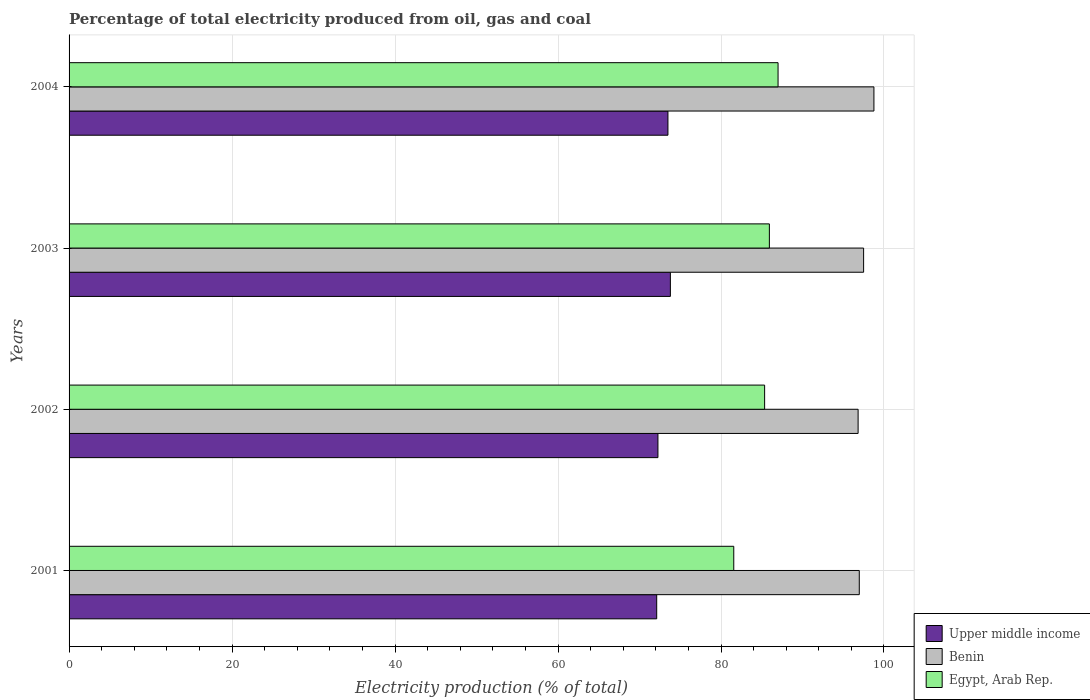Are the number of bars per tick equal to the number of legend labels?
Offer a terse response. Yes. What is the label of the 2nd group of bars from the top?
Ensure brevity in your answer.  2003. What is the electricity production in in Benin in 2001?
Provide a short and direct response. 96.97. Across all years, what is the maximum electricity production in in Egypt, Arab Rep.?
Provide a short and direct response. 87. Across all years, what is the minimum electricity production in in Upper middle income?
Your answer should be very brief. 72.11. In which year was the electricity production in in Egypt, Arab Rep. minimum?
Your answer should be compact. 2001. What is the total electricity production in in Upper middle income in the graph?
Your response must be concise. 291.65. What is the difference between the electricity production in in Upper middle income in 2002 and that in 2004?
Offer a very short reply. -1.23. What is the difference between the electricity production in in Egypt, Arab Rep. in 2004 and the electricity production in in Upper middle income in 2001?
Offer a terse response. 14.89. What is the average electricity production in in Upper middle income per year?
Your answer should be very brief. 72.91. In the year 2001, what is the difference between the electricity production in in Egypt, Arab Rep. and electricity production in in Benin?
Offer a very short reply. -15.4. In how many years, is the electricity production in in Egypt, Arab Rep. greater than 60 %?
Make the answer very short. 4. What is the ratio of the electricity production in in Upper middle income in 2002 to that in 2004?
Your response must be concise. 0.98. Is the electricity production in in Egypt, Arab Rep. in 2003 less than that in 2004?
Offer a very short reply. Yes. Is the difference between the electricity production in in Egypt, Arab Rep. in 2001 and 2002 greater than the difference between the electricity production in in Benin in 2001 and 2002?
Provide a short and direct response. No. What is the difference between the highest and the second highest electricity production in in Upper middle income?
Offer a terse response. 0.3. What is the difference between the highest and the lowest electricity production in in Upper middle income?
Keep it short and to the point. 1.68. In how many years, is the electricity production in in Egypt, Arab Rep. greater than the average electricity production in in Egypt, Arab Rep. taken over all years?
Your response must be concise. 3. Is the sum of the electricity production in in Benin in 2001 and 2004 greater than the maximum electricity production in in Egypt, Arab Rep. across all years?
Provide a succinct answer. Yes. What does the 3rd bar from the top in 2003 represents?
Give a very brief answer. Upper middle income. What does the 2nd bar from the bottom in 2001 represents?
Ensure brevity in your answer.  Benin. Is it the case that in every year, the sum of the electricity production in in Upper middle income and electricity production in in Benin is greater than the electricity production in in Egypt, Arab Rep.?
Your answer should be very brief. Yes. What is the difference between two consecutive major ticks on the X-axis?
Your response must be concise. 20. Does the graph contain any zero values?
Give a very brief answer. No. How many legend labels are there?
Give a very brief answer. 3. What is the title of the graph?
Offer a very short reply. Percentage of total electricity produced from oil, gas and coal. What is the label or title of the X-axis?
Your answer should be very brief. Electricity production (% of total). What is the label or title of the Y-axis?
Provide a short and direct response. Years. What is the Electricity production (% of total) in Upper middle income in 2001?
Give a very brief answer. 72.11. What is the Electricity production (% of total) of Benin in 2001?
Your answer should be compact. 96.97. What is the Electricity production (% of total) of Egypt, Arab Rep. in 2001?
Ensure brevity in your answer.  81.57. What is the Electricity production (% of total) in Upper middle income in 2002?
Your answer should be compact. 72.26. What is the Electricity production (% of total) in Benin in 2002?
Your answer should be very brief. 96.83. What is the Electricity production (% of total) of Egypt, Arab Rep. in 2002?
Provide a short and direct response. 85.35. What is the Electricity production (% of total) of Upper middle income in 2003?
Your answer should be very brief. 73.79. What is the Electricity production (% of total) in Benin in 2003?
Keep it short and to the point. 97.5. What is the Electricity production (% of total) in Egypt, Arab Rep. in 2003?
Ensure brevity in your answer.  85.94. What is the Electricity production (% of total) of Upper middle income in 2004?
Provide a short and direct response. 73.49. What is the Electricity production (% of total) of Benin in 2004?
Your answer should be very brief. 98.77. What is the Electricity production (% of total) in Egypt, Arab Rep. in 2004?
Ensure brevity in your answer.  87. Across all years, what is the maximum Electricity production (% of total) in Upper middle income?
Ensure brevity in your answer.  73.79. Across all years, what is the maximum Electricity production (% of total) of Benin?
Provide a succinct answer. 98.77. Across all years, what is the maximum Electricity production (% of total) in Egypt, Arab Rep.?
Your response must be concise. 87. Across all years, what is the minimum Electricity production (% of total) of Upper middle income?
Keep it short and to the point. 72.11. Across all years, what is the minimum Electricity production (% of total) in Benin?
Your response must be concise. 96.83. Across all years, what is the minimum Electricity production (% of total) in Egypt, Arab Rep.?
Ensure brevity in your answer.  81.57. What is the total Electricity production (% of total) of Upper middle income in the graph?
Keep it short and to the point. 291.65. What is the total Electricity production (% of total) in Benin in the graph?
Offer a very short reply. 390.06. What is the total Electricity production (% of total) in Egypt, Arab Rep. in the graph?
Offer a very short reply. 339.86. What is the difference between the Electricity production (% of total) in Upper middle income in 2001 and that in 2002?
Your answer should be very brief. -0.15. What is the difference between the Electricity production (% of total) of Benin in 2001 and that in 2002?
Give a very brief answer. 0.14. What is the difference between the Electricity production (% of total) in Egypt, Arab Rep. in 2001 and that in 2002?
Give a very brief answer. -3.79. What is the difference between the Electricity production (% of total) of Upper middle income in 2001 and that in 2003?
Provide a short and direct response. -1.68. What is the difference between the Electricity production (% of total) of Benin in 2001 and that in 2003?
Your answer should be compact. -0.53. What is the difference between the Electricity production (% of total) in Egypt, Arab Rep. in 2001 and that in 2003?
Your answer should be very brief. -4.37. What is the difference between the Electricity production (% of total) in Upper middle income in 2001 and that in 2004?
Make the answer very short. -1.38. What is the difference between the Electricity production (% of total) in Benin in 2001 and that in 2004?
Give a very brief answer. -1.8. What is the difference between the Electricity production (% of total) in Egypt, Arab Rep. in 2001 and that in 2004?
Provide a short and direct response. -5.43. What is the difference between the Electricity production (% of total) of Upper middle income in 2002 and that in 2003?
Your answer should be compact. -1.53. What is the difference between the Electricity production (% of total) in Benin in 2002 and that in 2003?
Offer a terse response. -0.67. What is the difference between the Electricity production (% of total) in Egypt, Arab Rep. in 2002 and that in 2003?
Give a very brief answer. -0.58. What is the difference between the Electricity production (% of total) in Upper middle income in 2002 and that in 2004?
Your response must be concise. -1.23. What is the difference between the Electricity production (% of total) of Benin in 2002 and that in 2004?
Your response must be concise. -1.94. What is the difference between the Electricity production (% of total) of Egypt, Arab Rep. in 2002 and that in 2004?
Provide a short and direct response. -1.65. What is the difference between the Electricity production (% of total) in Upper middle income in 2003 and that in 2004?
Your answer should be compact. 0.3. What is the difference between the Electricity production (% of total) in Benin in 2003 and that in 2004?
Give a very brief answer. -1.27. What is the difference between the Electricity production (% of total) of Egypt, Arab Rep. in 2003 and that in 2004?
Your response must be concise. -1.07. What is the difference between the Electricity production (% of total) in Upper middle income in 2001 and the Electricity production (% of total) in Benin in 2002?
Give a very brief answer. -24.72. What is the difference between the Electricity production (% of total) of Upper middle income in 2001 and the Electricity production (% of total) of Egypt, Arab Rep. in 2002?
Keep it short and to the point. -13.24. What is the difference between the Electricity production (% of total) of Benin in 2001 and the Electricity production (% of total) of Egypt, Arab Rep. in 2002?
Your answer should be very brief. 11.62. What is the difference between the Electricity production (% of total) of Upper middle income in 2001 and the Electricity production (% of total) of Benin in 2003?
Give a very brief answer. -25.39. What is the difference between the Electricity production (% of total) of Upper middle income in 2001 and the Electricity production (% of total) of Egypt, Arab Rep. in 2003?
Keep it short and to the point. -13.83. What is the difference between the Electricity production (% of total) of Benin in 2001 and the Electricity production (% of total) of Egypt, Arab Rep. in 2003?
Offer a terse response. 11.03. What is the difference between the Electricity production (% of total) in Upper middle income in 2001 and the Electricity production (% of total) in Benin in 2004?
Provide a short and direct response. -26.66. What is the difference between the Electricity production (% of total) in Upper middle income in 2001 and the Electricity production (% of total) in Egypt, Arab Rep. in 2004?
Ensure brevity in your answer.  -14.89. What is the difference between the Electricity production (% of total) of Benin in 2001 and the Electricity production (% of total) of Egypt, Arab Rep. in 2004?
Offer a terse response. 9.97. What is the difference between the Electricity production (% of total) in Upper middle income in 2002 and the Electricity production (% of total) in Benin in 2003?
Ensure brevity in your answer.  -25.24. What is the difference between the Electricity production (% of total) in Upper middle income in 2002 and the Electricity production (% of total) in Egypt, Arab Rep. in 2003?
Offer a terse response. -13.67. What is the difference between the Electricity production (% of total) in Benin in 2002 and the Electricity production (% of total) in Egypt, Arab Rep. in 2003?
Ensure brevity in your answer.  10.89. What is the difference between the Electricity production (% of total) in Upper middle income in 2002 and the Electricity production (% of total) in Benin in 2004?
Your answer should be very brief. -26.5. What is the difference between the Electricity production (% of total) of Upper middle income in 2002 and the Electricity production (% of total) of Egypt, Arab Rep. in 2004?
Ensure brevity in your answer.  -14.74. What is the difference between the Electricity production (% of total) of Benin in 2002 and the Electricity production (% of total) of Egypt, Arab Rep. in 2004?
Your answer should be compact. 9.82. What is the difference between the Electricity production (% of total) in Upper middle income in 2003 and the Electricity production (% of total) in Benin in 2004?
Give a very brief answer. -24.98. What is the difference between the Electricity production (% of total) of Upper middle income in 2003 and the Electricity production (% of total) of Egypt, Arab Rep. in 2004?
Your answer should be compact. -13.21. What is the difference between the Electricity production (% of total) of Benin in 2003 and the Electricity production (% of total) of Egypt, Arab Rep. in 2004?
Offer a very short reply. 10.5. What is the average Electricity production (% of total) of Upper middle income per year?
Your answer should be compact. 72.91. What is the average Electricity production (% of total) in Benin per year?
Keep it short and to the point. 97.52. What is the average Electricity production (% of total) in Egypt, Arab Rep. per year?
Ensure brevity in your answer.  84.96. In the year 2001, what is the difference between the Electricity production (% of total) of Upper middle income and Electricity production (% of total) of Benin?
Offer a terse response. -24.86. In the year 2001, what is the difference between the Electricity production (% of total) in Upper middle income and Electricity production (% of total) in Egypt, Arab Rep.?
Keep it short and to the point. -9.46. In the year 2001, what is the difference between the Electricity production (% of total) of Benin and Electricity production (% of total) of Egypt, Arab Rep.?
Give a very brief answer. 15.4. In the year 2002, what is the difference between the Electricity production (% of total) in Upper middle income and Electricity production (% of total) in Benin?
Offer a very short reply. -24.56. In the year 2002, what is the difference between the Electricity production (% of total) in Upper middle income and Electricity production (% of total) in Egypt, Arab Rep.?
Your answer should be compact. -13.09. In the year 2002, what is the difference between the Electricity production (% of total) of Benin and Electricity production (% of total) of Egypt, Arab Rep.?
Your response must be concise. 11.47. In the year 2003, what is the difference between the Electricity production (% of total) in Upper middle income and Electricity production (% of total) in Benin?
Provide a succinct answer. -23.71. In the year 2003, what is the difference between the Electricity production (% of total) of Upper middle income and Electricity production (% of total) of Egypt, Arab Rep.?
Your answer should be compact. -12.15. In the year 2003, what is the difference between the Electricity production (% of total) in Benin and Electricity production (% of total) in Egypt, Arab Rep.?
Ensure brevity in your answer.  11.56. In the year 2004, what is the difference between the Electricity production (% of total) of Upper middle income and Electricity production (% of total) of Benin?
Your response must be concise. -25.28. In the year 2004, what is the difference between the Electricity production (% of total) of Upper middle income and Electricity production (% of total) of Egypt, Arab Rep.?
Ensure brevity in your answer.  -13.51. In the year 2004, what is the difference between the Electricity production (% of total) of Benin and Electricity production (% of total) of Egypt, Arab Rep.?
Your answer should be compact. 11.76. What is the ratio of the Electricity production (% of total) in Upper middle income in 2001 to that in 2002?
Give a very brief answer. 1. What is the ratio of the Electricity production (% of total) in Egypt, Arab Rep. in 2001 to that in 2002?
Your response must be concise. 0.96. What is the ratio of the Electricity production (% of total) of Upper middle income in 2001 to that in 2003?
Offer a very short reply. 0.98. What is the ratio of the Electricity production (% of total) in Egypt, Arab Rep. in 2001 to that in 2003?
Offer a very short reply. 0.95. What is the ratio of the Electricity production (% of total) of Upper middle income in 2001 to that in 2004?
Your response must be concise. 0.98. What is the ratio of the Electricity production (% of total) in Benin in 2001 to that in 2004?
Make the answer very short. 0.98. What is the ratio of the Electricity production (% of total) in Egypt, Arab Rep. in 2001 to that in 2004?
Provide a succinct answer. 0.94. What is the ratio of the Electricity production (% of total) of Upper middle income in 2002 to that in 2003?
Provide a short and direct response. 0.98. What is the ratio of the Electricity production (% of total) of Benin in 2002 to that in 2003?
Ensure brevity in your answer.  0.99. What is the ratio of the Electricity production (% of total) of Egypt, Arab Rep. in 2002 to that in 2003?
Ensure brevity in your answer.  0.99. What is the ratio of the Electricity production (% of total) in Upper middle income in 2002 to that in 2004?
Your answer should be compact. 0.98. What is the ratio of the Electricity production (% of total) in Benin in 2002 to that in 2004?
Provide a succinct answer. 0.98. What is the ratio of the Electricity production (% of total) of Egypt, Arab Rep. in 2002 to that in 2004?
Ensure brevity in your answer.  0.98. What is the ratio of the Electricity production (% of total) in Upper middle income in 2003 to that in 2004?
Your answer should be very brief. 1. What is the ratio of the Electricity production (% of total) of Benin in 2003 to that in 2004?
Your response must be concise. 0.99. What is the ratio of the Electricity production (% of total) in Egypt, Arab Rep. in 2003 to that in 2004?
Give a very brief answer. 0.99. What is the difference between the highest and the second highest Electricity production (% of total) of Upper middle income?
Your response must be concise. 0.3. What is the difference between the highest and the second highest Electricity production (% of total) of Benin?
Give a very brief answer. 1.27. What is the difference between the highest and the second highest Electricity production (% of total) of Egypt, Arab Rep.?
Your answer should be very brief. 1.07. What is the difference between the highest and the lowest Electricity production (% of total) of Upper middle income?
Provide a succinct answer. 1.68. What is the difference between the highest and the lowest Electricity production (% of total) in Benin?
Your response must be concise. 1.94. What is the difference between the highest and the lowest Electricity production (% of total) in Egypt, Arab Rep.?
Give a very brief answer. 5.43. 